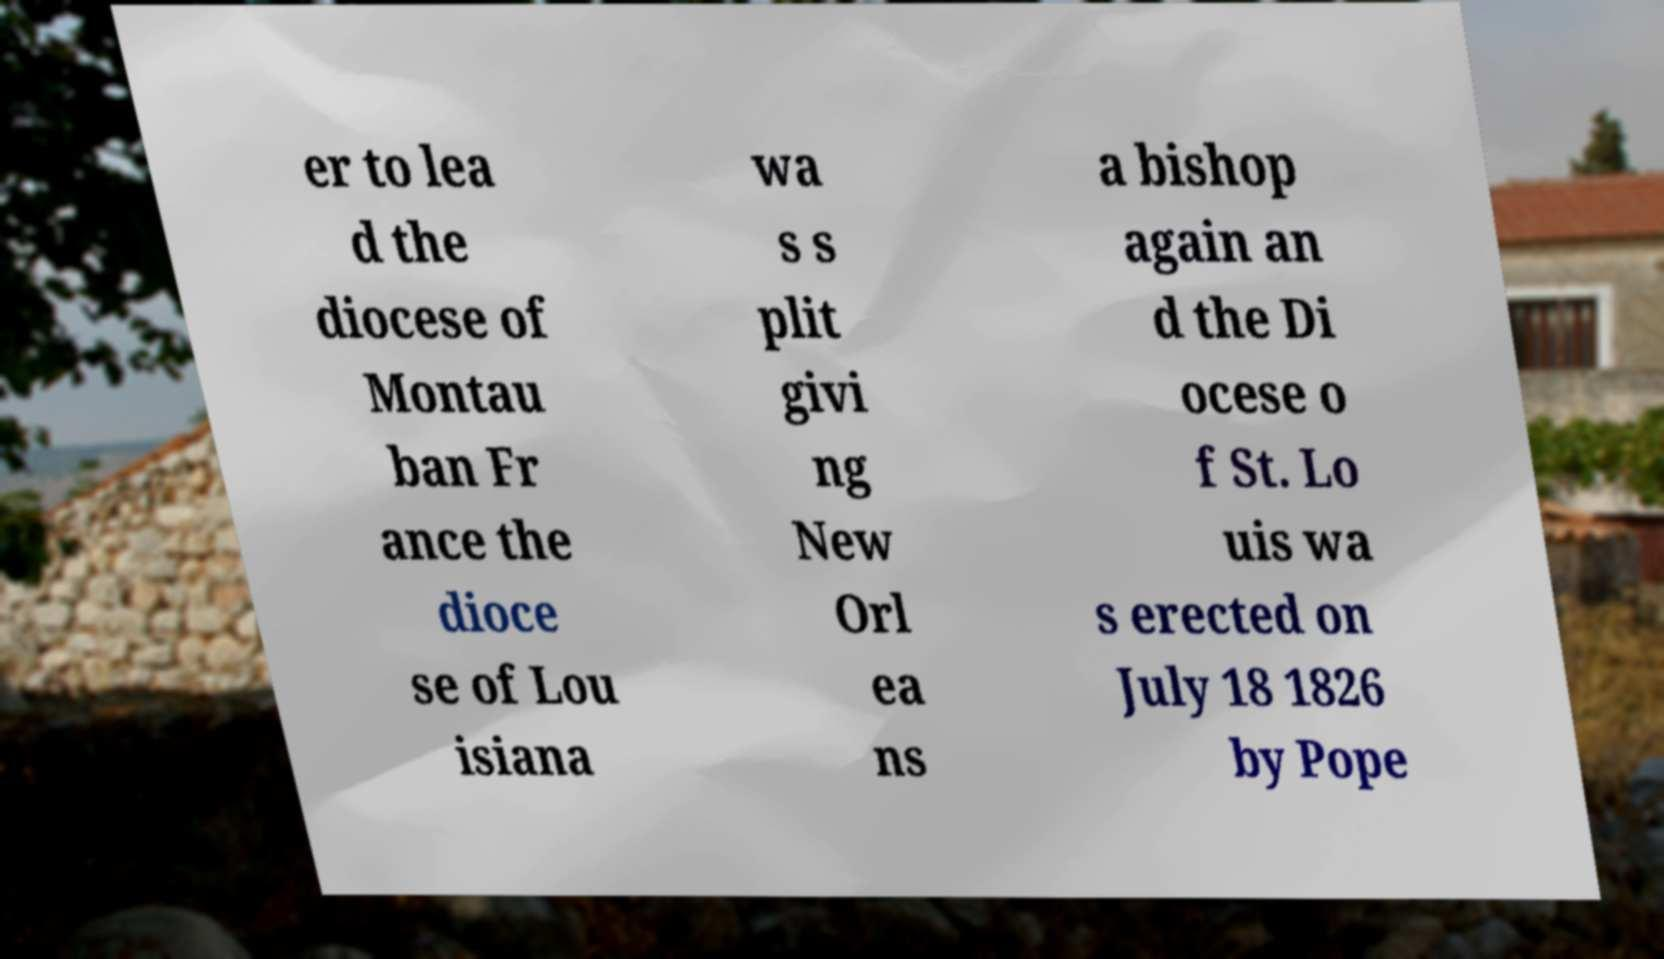Could you extract and type out the text from this image? er to lea d the diocese of Montau ban Fr ance the dioce se of Lou isiana wa s s plit givi ng New Orl ea ns a bishop again an d the Di ocese o f St. Lo uis wa s erected on July 18 1826 by Pope 